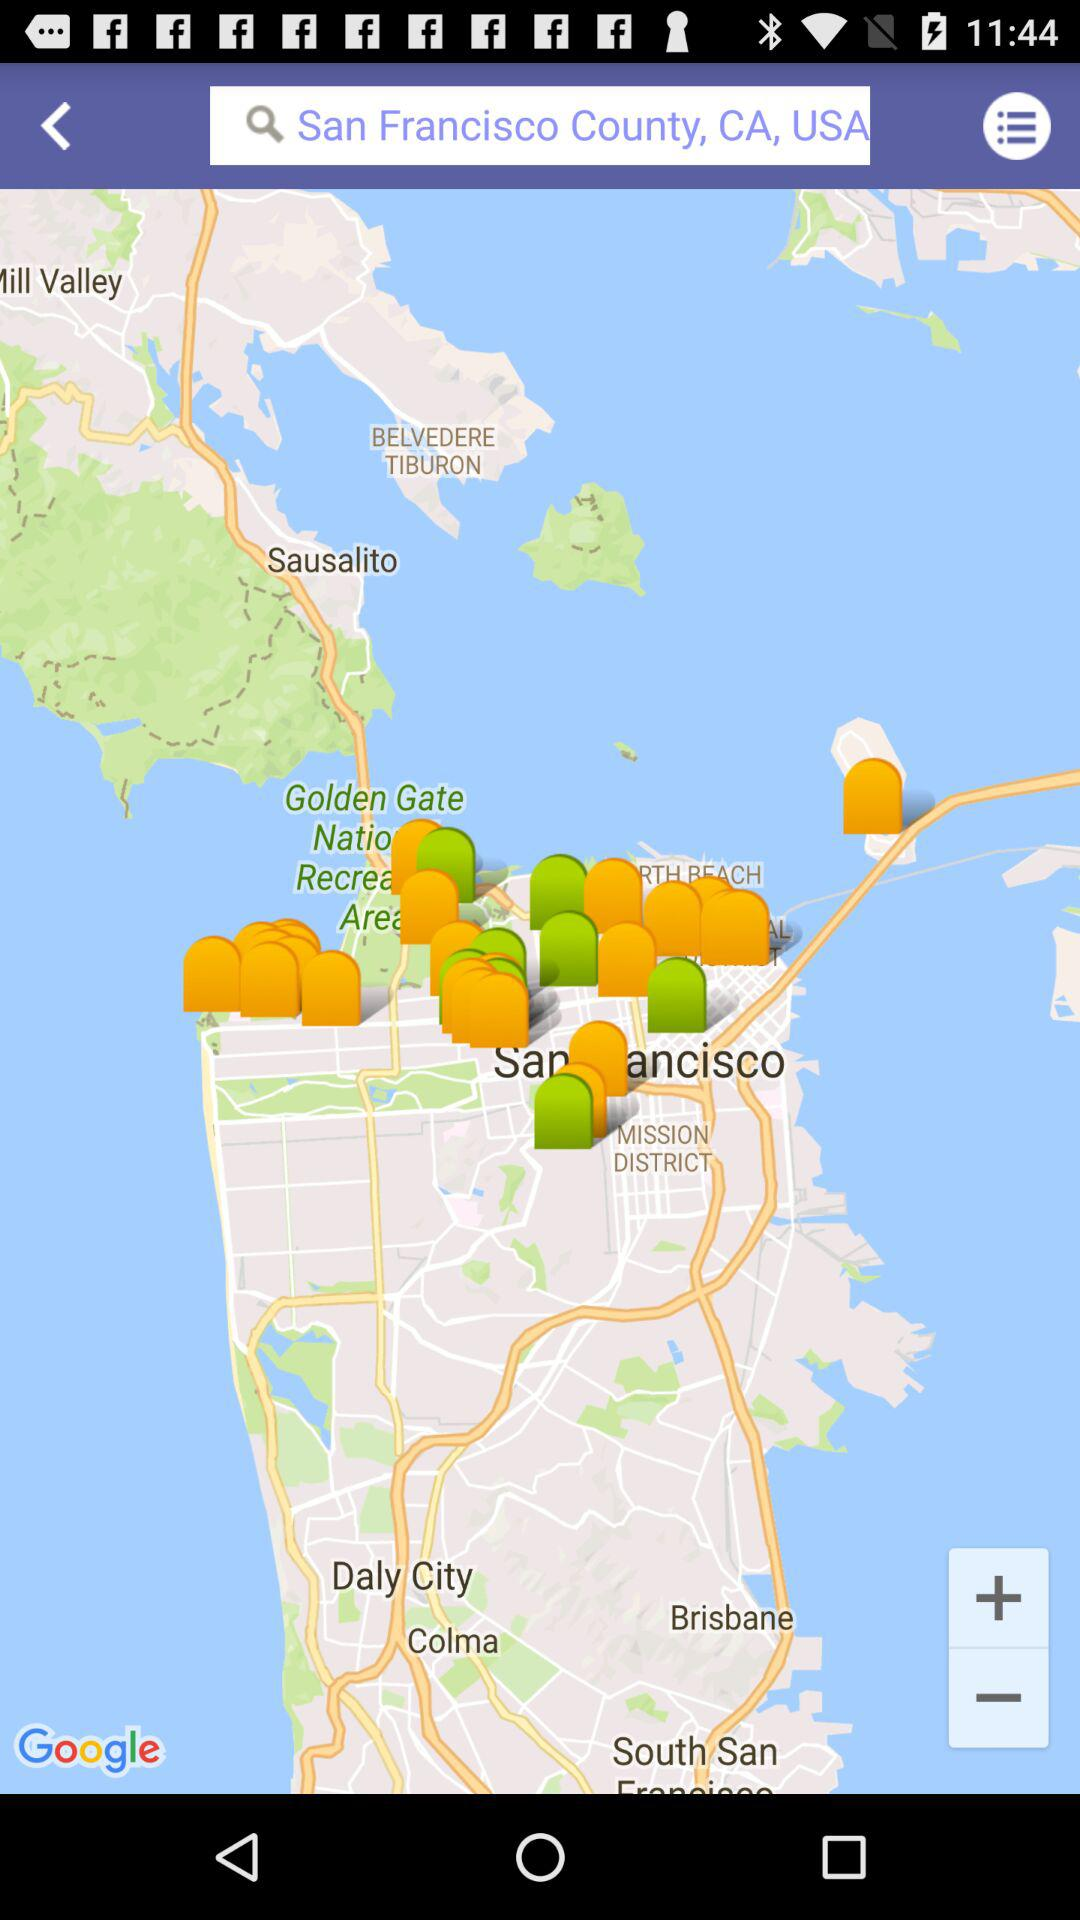What text is in the input field? The text in the input field is San Francisco County, CA, USA. 